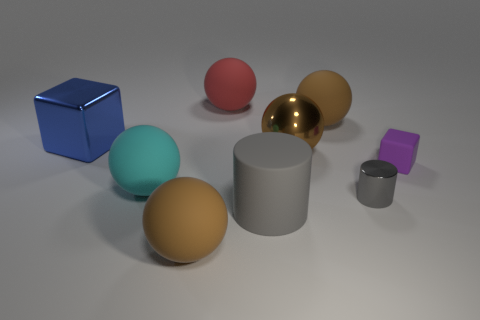Subtract all purple cubes. How many brown balls are left? 3 Subtract all red rubber spheres. How many spheres are left? 4 Subtract 2 balls. How many balls are left? 3 Subtract all blue spheres. Subtract all cyan blocks. How many spheres are left? 5 Add 1 cyan metallic cylinders. How many objects exist? 10 Subtract all balls. How many objects are left? 4 Add 2 small gray things. How many small gray things are left? 3 Add 6 brown rubber balls. How many brown rubber balls exist? 8 Subtract 0 yellow blocks. How many objects are left? 9 Subtract all tiny metal things. Subtract all blue shiny blocks. How many objects are left? 7 